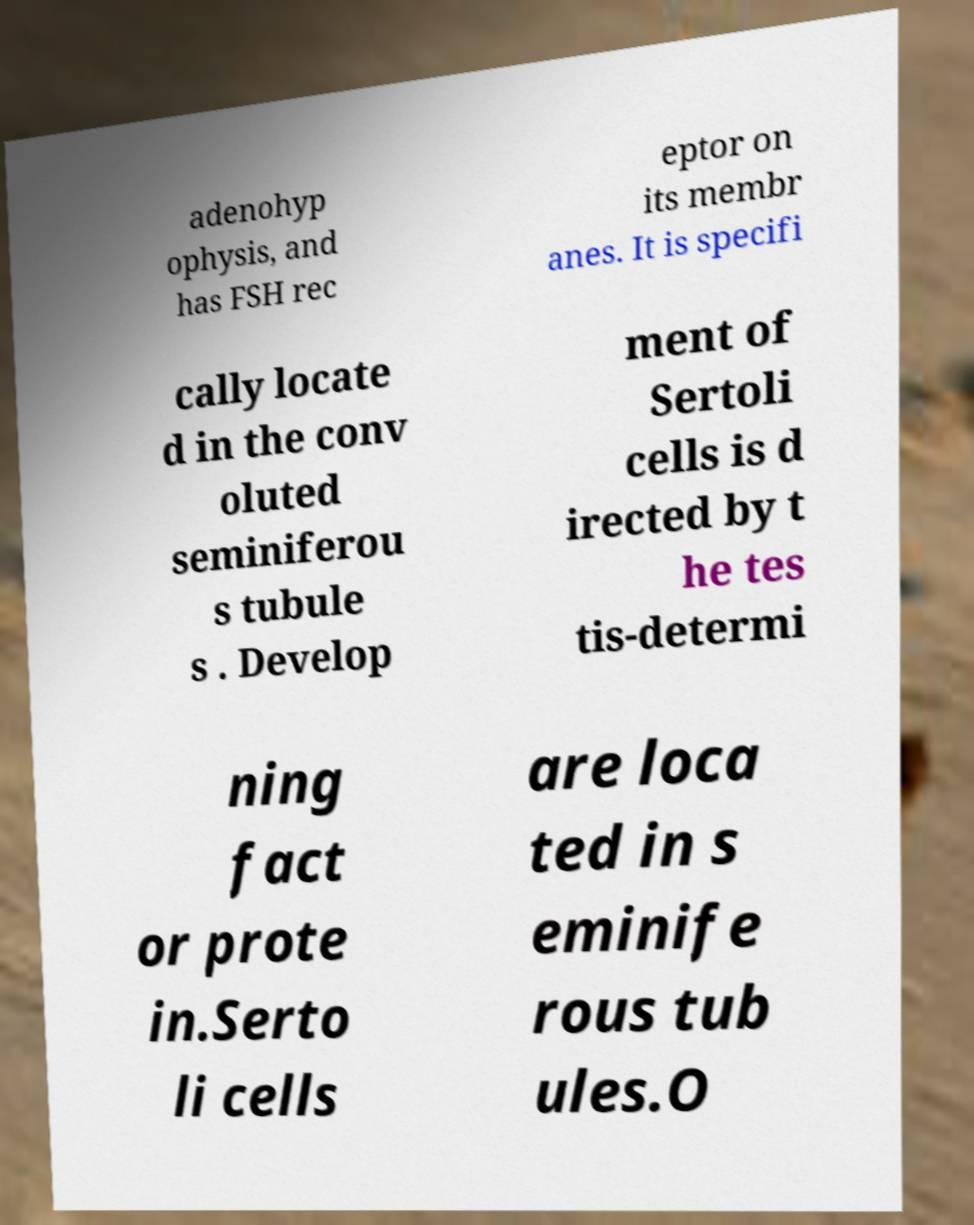Can you accurately transcribe the text from the provided image for me? adenohyp ophysis, and has FSH rec eptor on its membr anes. It is specifi cally locate d in the conv oluted seminiferou s tubule s . Develop ment of Sertoli cells is d irected by t he tes tis-determi ning fact or prote in.Serto li cells are loca ted in s eminife rous tub ules.O 